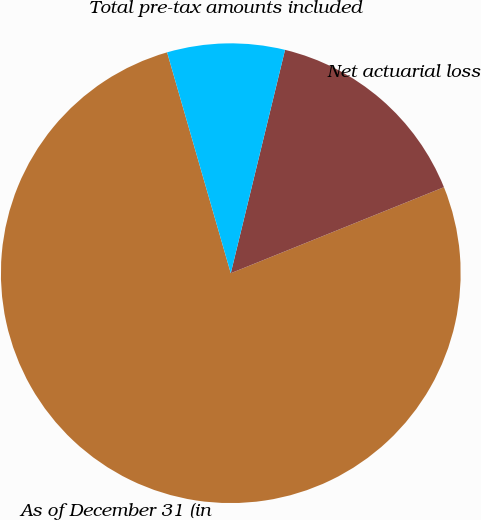Convert chart to OTSL. <chart><loc_0><loc_0><loc_500><loc_500><pie_chart><fcel>As of December 31 (in<fcel>Net actuarial loss<fcel>Total pre-tax amounts included<nl><fcel>76.63%<fcel>15.1%<fcel>8.26%<nl></chart> 